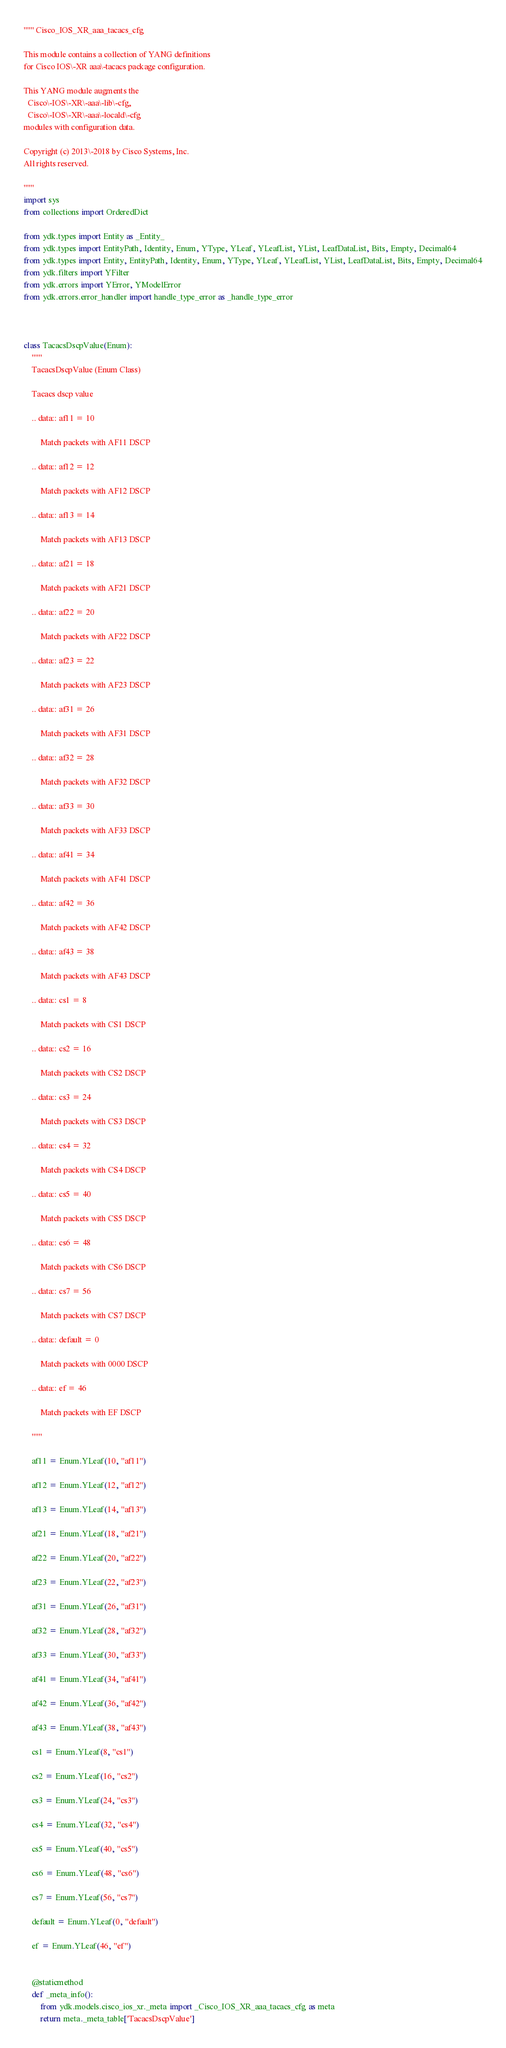<code> <loc_0><loc_0><loc_500><loc_500><_Python_>""" Cisco_IOS_XR_aaa_tacacs_cfg 

This module contains a collection of YANG definitions
for Cisco IOS\-XR aaa\-tacacs package configuration.

This YANG module augments the
  Cisco\-IOS\-XR\-aaa\-lib\-cfg,
  Cisco\-IOS\-XR\-aaa\-locald\-cfg
modules with configuration data.

Copyright (c) 2013\-2018 by Cisco Systems, Inc.
All rights reserved.

"""
import sys
from collections import OrderedDict

from ydk.types import Entity as _Entity_
from ydk.types import EntityPath, Identity, Enum, YType, YLeaf, YLeafList, YList, LeafDataList, Bits, Empty, Decimal64
from ydk.types import Entity, EntityPath, Identity, Enum, YType, YLeaf, YLeafList, YList, LeafDataList, Bits, Empty, Decimal64
from ydk.filters import YFilter
from ydk.errors import YError, YModelError
from ydk.errors.error_handler import handle_type_error as _handle_type_error



class TacacsDscpValue(Enum):
    """
    TacacsDscpValue (Enum Class)

    Tacacs dscp value

    .. data:: af11 = 10

    	Match packets with AF11 DSCP

    .. data:: af12 = 12

    	Match packets with AF12 DSCP

    .. data:: af13 = 14

    	Match packets with AF13 DSCP

    .. data:: af21 = 18

    	Match packets with AF21 DSCP

    .. data:: af22 = 20

    	Match packets with AF22 DSCP

    .. data:: af23 = 22

    	Match packets with AF23 DSCP

    .. data:: af31 = 26

    	Match packets with AF31 DSCP

    .. data:: af32 = 28

    	Match packets with AF32 DSCP

    .. data:: af33 = 30

    	Match packets with AF33 DSCP

    .. data:: af41 = 34

    	Match packets with AF41 DSCP

    .. data:: af42 = 36

    	Match packets with AF42 DSCP

    .. data:: af43 = 38

    	Match packets with AF43 DSCP

    .. data:: cs1 = 8

    	Match packets with CS1 DSCP

    .. data:: cs2 = 16

    	Match packets with CS2 DSCP

    .. data:: cs3 = 24

    	Match packets with CS3 DSCP

    .. data:: cs4 = 32

    	Match packets with CS4 DSCP

    .. data:: cs5 = 40

    	Match packets with CS5 DSCP

    .. data:: cs6 = 48

    	Match packets with CS6 DSCP

    .. data:: cs7 = 56

    	Match packets with CS7 DSCP

    .. data:: default = 0

    	Match packets with 0000 DSCP

    .. data:: ef = 46

    	Match packets with EF DSCP

    """

    af11 = Enum.YLeaf(10, "af11")

    af12 = Enum.YLeaf(12, "af12")

    af13 = Enum.YLeaf(14, "af13")

    af21 = Enum.YLeaf(18, "af21")

    af22 = Enum.YLeaf(20, "af22")

    af23 = Enum.YLeaf(22, "af23")

    af31 = Enum.YLeaf(26, "af31")

    af32 = Enum.YLeaf(28, "af32")

    af33 = Enum.YLeaf(30, "af33")

    af41 = Enum.YLeaf(34, "af41")

    af42 = Enum.YLeaf(36, "af42")

    af43 = Enum.YLeaf(38, "af43")

    cs1 = Enum.YLeaf(8, "cs1")

    cs2 = Enum.YLeaf(16, "cs2")

    cs3 = Enum.YLeaf(24, "cs3")

    cs4 = Enum.YLeaf(32, "cs4")

    cs5 = Enum.YLeaf(40, "cs5")

    cs6 = Enum.YLeaf(48, "cs6")

    cs7 = Enum.YLeaf(56, "cs7")

    default = Enum.YLeaf(0, "default")

    ef = Enum.YLeaf(46, "ef")


    @staticmethod
    def _meta_info():
        from ydk.models.cisco_ios_xr._meta import _Cisco_IOS_XR_aaa_tacacs_cfg as meta
        return meta._meta_table['TacacsDscpValue']



</code> 